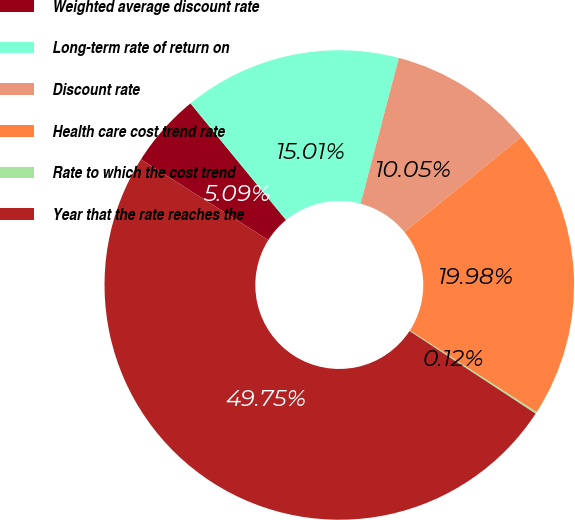<chart> <loc_0><loc_0><loc_500><loc_500><pie_chart><fcel>Weighted average discount rate<fcel>Long-term rate of return on<fcel>Discount rate<fcel>Health care cost trend rate<fcel>Rate to which the cost trend<fcel>Year that the rate reaches the<nl><fcel>5.09%<fcel>15.01%<fcel>10.05%<fcel>19.98%<fcel>0.12%<fcel>49.75%<nl></chart> 